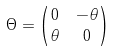Convert formula to latex. <formula><loc_0><loc_0><loc_500><loc_500>\Theta = & \begin{pmatrix} 0 & - \theta \\ \theta & 0 \end{pmatrix}</formula> 